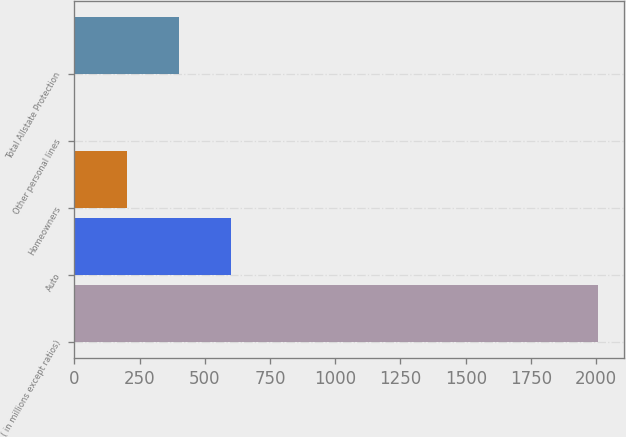Convert chart. <chart><loc_0><loc_0><loc_500><loc_500><bar_chart><fcel>( in millions except ratios)<fcel>Auto<fcel>Homeowners<fcel>Other personal lines<fcel>Total Allstate Protection<nl><fcel>2007<fcel>602.17<fcel>200.79<fcel>0.1<fcel>401.48<nl></chart> 